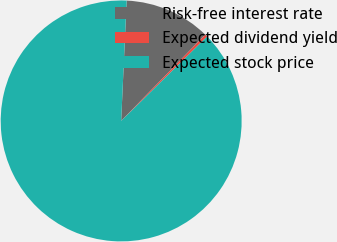Convert chart. <chart><loc_0><loc_0><loc_500><loc_500><pie_chart><fcel>Risk-free interest rate<fcel>Expected dividend yield<fcel>Expected stock price<nl><fcel>11.57%<fcel>0.35%<fcel>88.09%<nl></chart> 